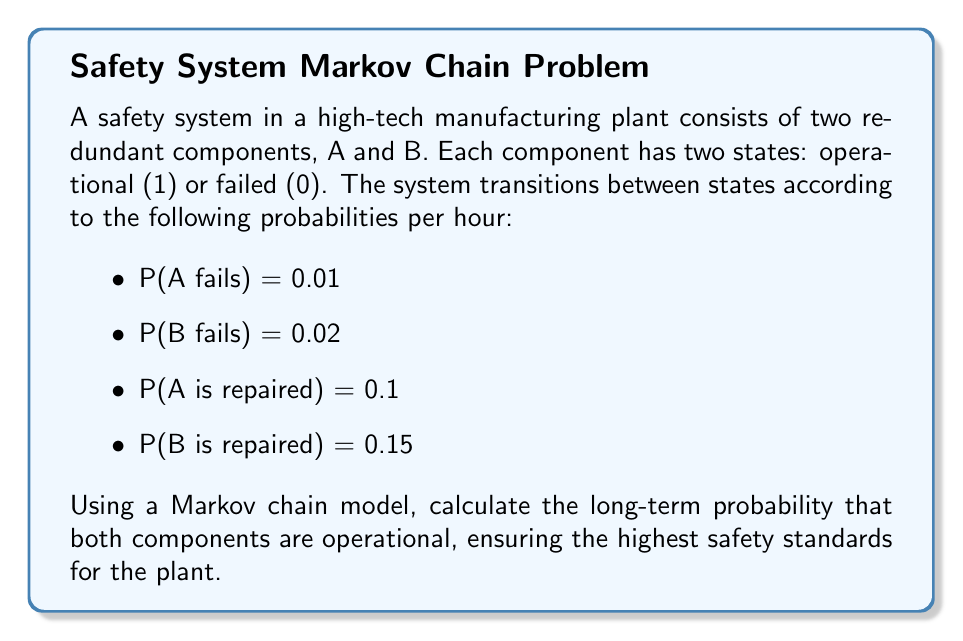Teach me how to tackle this problem. To solve this problem, we'll follow these steps:

1) First, let's define the states of our Markov chain:
   State 1: Both A and B operational (1,1)
   State 2: A operational, B failed (1,0)
   State 3: A failed, B operational (0,1)
   State 4: Both A and B failed (0,0)

2) Now, we can construct the transition probability matrix P:

   $$P = \begin{bmatrix}
   0.97 & 0.02 & 0.01 & 0 \\
   0.15 & 0.84 & 0 & 0.01 \\
   0.1 & 0 & 0.88 & 0.02 \\
   0 & 0.1 & 0.15 & 0.75
   \end{bmatrix}$$

3) To find the long-term probabilities, we need to solve the equation:
   
   $$\pi P = \pi$$

   where $\pi = [\pi_1, \pi_2, \pi_3, \pi_4]$ is the stationary distribution.

4) This gives us the following system of equations:

   $$\begin{align}
   0.97\pi_1 + 0.15\pi_2 + 0.1\pi_3 &= \pi_1 \\
   0.02\pi_1 + 0.84\pi_2 + 0.1\pi_4 &= \pi_2 \\
   0.01\pi_1 + 0.88\pi_3 + 0.15\pi_4 &= \pi_3 \\
   0.01\pi_2 + 0.02\pi_3 + 0.75\pi_4 &= \pi_4
   \end{align}$$

5) We also know that the probabilities must sum to 1:

   $$\pi_1 + \pi_2 + \pi_3 + \pi_4 = 1$$

6) Solving this system of equations (which can be done using linear algebra methods or numerical solvers), we get:

   $$\begin{align}
   \pi_1 &\approx 0.8696 \\
   \pi_2 &\approx 0.0870 \\
   \pi_3 &\approx 0.0435 \\
   \pi_4 &\approx 0.0000
   \end{align}$$

7) The long-term probability that both components are operational is $\pi_1 \approx 0.8696$ or about 86.96%.
Answer: 0.8696 